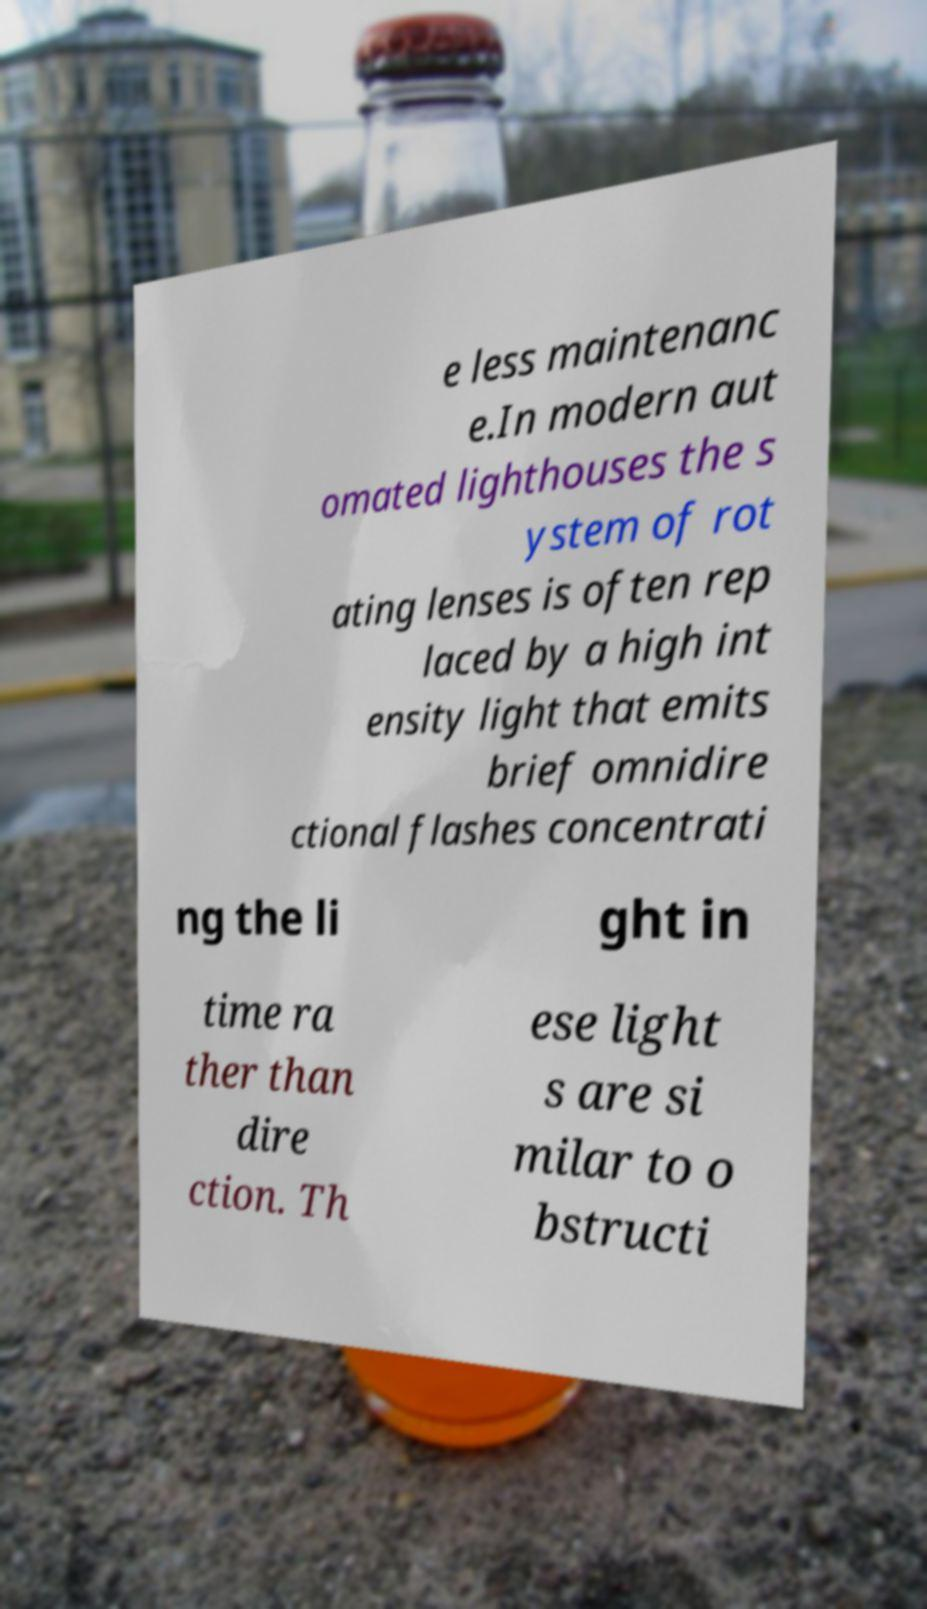There's text embedded in this image that I need extracted. Can you transcribe it verbatim? e less maintenanc e.In modern aut omated lighthouses the s ystem of rot ating lenses is often rep laced by a high int ensity light that emits brief omnidire ctional flashes concentrati ng the li ght in time ra ther than dire ction. Th ese light s are si milar to o bstructi 